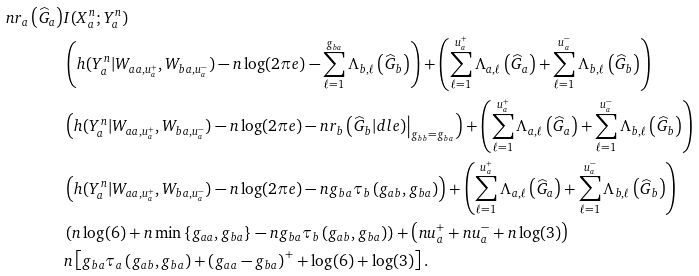Convert formula to latex. <formula><loc_0><loc_0><loc_500><loc_500>n r _ { a } \left ( \widehat { G } _ { a } \right ) & I ( X _ { a } ^ { n } ; Y _ { a } ^ { n } ) \\ & \left ( h ( Y _ { a } ^ { n } | W _ { a a , u _ { a } ^ { + } } , W _ { b a , u _ { a } ^ { - } } ) - n \log ( 2 \pi e ) - \sum _ { \ell = 1 } ^ { g _ { b a } } \Lambda _ { b , \ell } \left ( \widehat { G } _ { b } \right ) \right ) + \left ( \sum _ { \ell = 1 } ^ { u _ { a } ^ { + } } \Lambda _ { a , \ell } \left ( \widehat { G } _ { a } \right ) + \sum _ { \ell = 1 } ^ { u _ { a } ^ { - } } \Lambda _ { b , \ell } \left ( \widehat { G } _ { b } \right ) \right ) \\ & \left ( h ( Y _ { a } ^ { n } | W _ { a a , u _ { a } ^ { + } } , W _ { b a , u _ { a } ^ { - } } ) - n \log ( 2 \pi e ) - n r _ { b } \left ( \widehat { G } _ { b } | d l e ) \right | _ { g _ { b b } = g _ { b a } } \right ) + \left ( \sum _ { \ell = 1 } ^ { u _ { a } ^ { + } } \Lambda _ { a , \ell } \left ( \widehat { G } _ { a } \right ) + \sum _ { \ell = 1 } ^ { u _ { a } ^ { - } } \Lambda _ { b , \ell } \left ( \widehat { G } _ { b } \right ) \right ) \\ & \left ( h ( Y _ { a } ^ { n } | W _ { a a , u _ { a } ^ { + } } , W _ { b a , u _ { a } ^ { - } } ) - n \log ( 2 \pi e ) - n g _ { b a } \tau _ { b } \left ( g _ { a b } , g _ { b a } \right ) \right ) + \left ( \sum _ { \ell = 1 } ^ { u _ { a } ^ { + } } \Lambda _ { a , \ell } \left ( \widehat { G } _ { a } \right ) + \sum _ { \ell = 1 } ^ { u _ { a } ^ { - } } \Lambda _ { b , \ell } \left ( \widehat { G } _ { b } \right ) \right ) \\ & \left ( n \log ( 6 ) + n \min \left \{ g _ { a a } , g _ { b a } \right \} - n g _ { b a } \tau _ { b } \left ( g _ { a b } , g _ { b a } \right ) \right ) + \left ( n u _ { a } ^ { + } + n u _ { a } ^ { - } + n \log ( 3 ) \right ) \\ & n \left [ g _ { b a } \tau _ { a } \left ( g _ { a b } , g _ { b a } \right ) + \left ( g _ { a a } - g _ { b a } \right ) ^ { + } + \log ( 6 ) + \log ( 3 ) \right ] .</formula> 